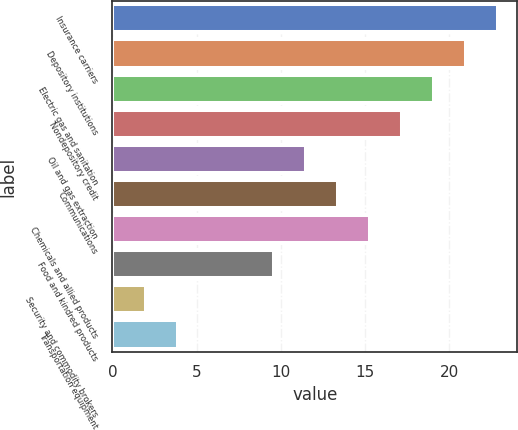Convert chart to OTSL. <chart><loc_0><loc_0><loc_500><loc_500><bar_chart><fcel>Insurance carriers<fcel>Depository institutions<fcel>Electric gas and sanitation<fcel>Nondepository credit<fcel>Oil and gas extraction<fcel>Communications<fcel>Chemicals and allied products<fcel>Food and kindred products<fcel>Security and commodity brokers<fcel>Transportation equipment<nl><fcel>22.9<fcel>21<fcel>19.1<fcel>17.2<fcel>11.5<fcel>13.4<fcel>15.3<fcel>9.6<fcel>2<fcel>3.9<nl></chart> 